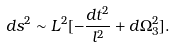<formula> <loc_0><loc_0><loc_500><loc_500>d s ^ { 2 } \sim L ^ { 2 } [ - \frac { d t ^ { 2 } } { l ^ { 2 } } + d \Omega ^ { 2 } _ { 3 } ] .</formula> 